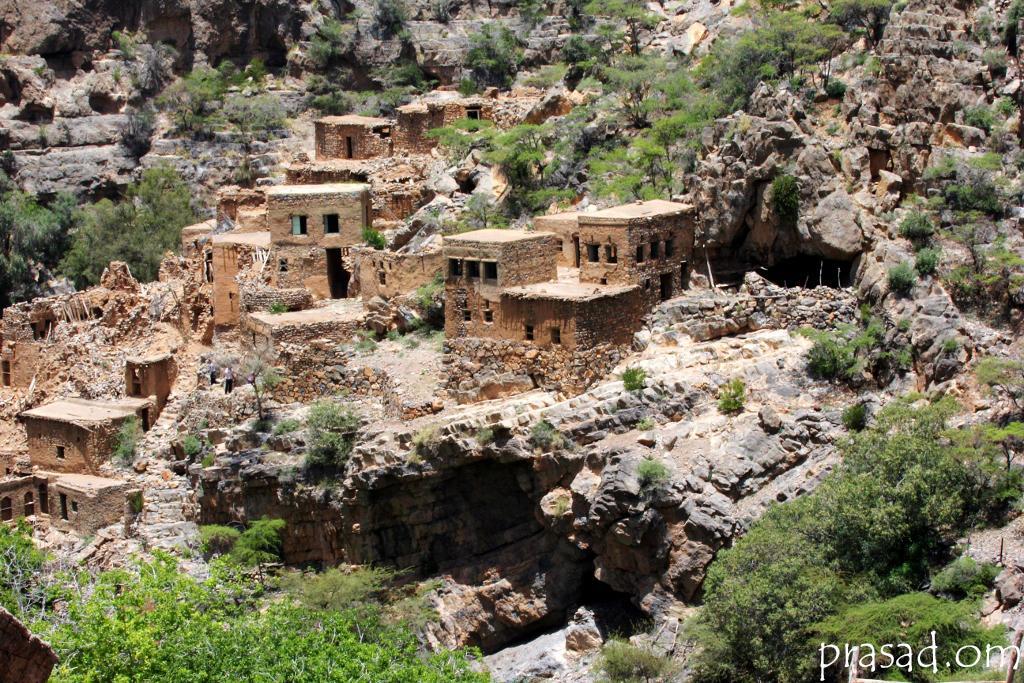Please provide a concise description of this image. In the image there are many brick buildings on the hills with trees and plants all over it. 